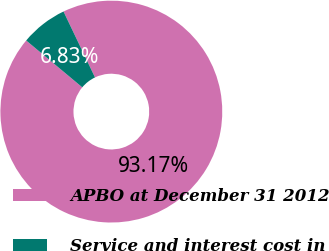Convert chart to OTSL. <chart><loc_0><loc_0><loc_500><loc_500><pie_chart><fcel>APBO at December 31 2012<fcel>Service and interest cost in<nl><fcel>93.17%<fcel>6.83%<nl></chart> 